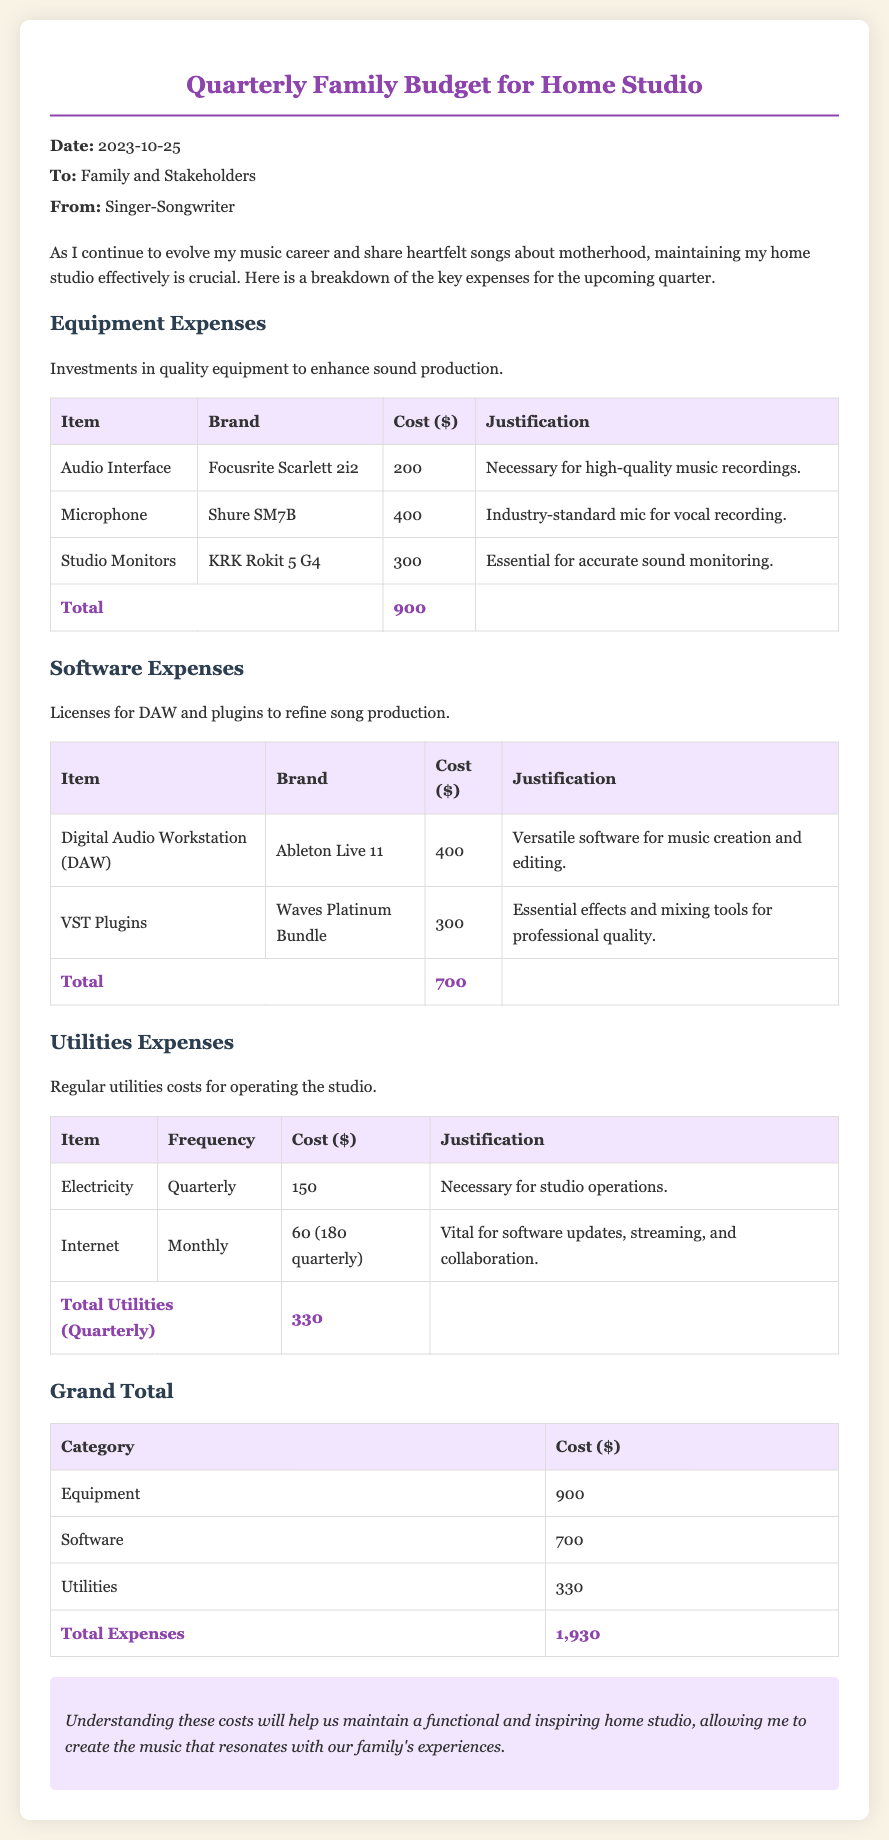what is the date of the memo? The memo is dated October 25, 2023, as stated in the header.
Answer: October 25, 2023 who is the memo addressed to? The memo is addressed to "Family and Stakeholders" in the header section.
Answer: Family and Stakeholders how much is budgeted for software expenses? The total for software expenses is found in the respective table section.
Answer: 700 what type of microphone is included in the equipment expenses? The document specifies "Shure SM7B" as the brand and type of microphone.
Answer: Shure SM7B what are the total utilities expenses for the quarter? The total utilities expenses can be found at the bottom of the utilities table.
Answer: 330 how much is allocated for the audio interface? The cost listed for the audio interface is presented in the equipment expenses table.
Answer: 200 what is the grand total of all expenses? The grand total is calculated by summing equipment, software, and utilities expenses.
Answer: 1,930 why is the internet cost described as vital? The justification in the document explains that internet is necessary for software updates, streaming, and collaboration.
Answer: Vital for software updates, streaming, and collaboration what is the justification for purchasing studio monitors? The document mentions that studio monitors are essential for accurate sound monitoring.
Answer: Essential for accurate sound monitoring 